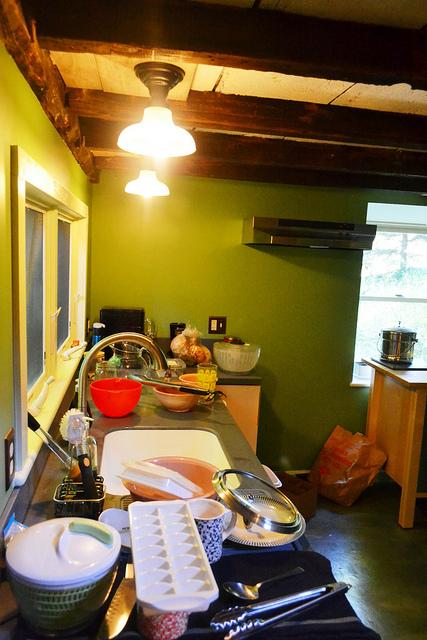What is the electrical device on the wall to the left of the window used for? Please explain your reasoning. hvac. The bulb is used to give light. 